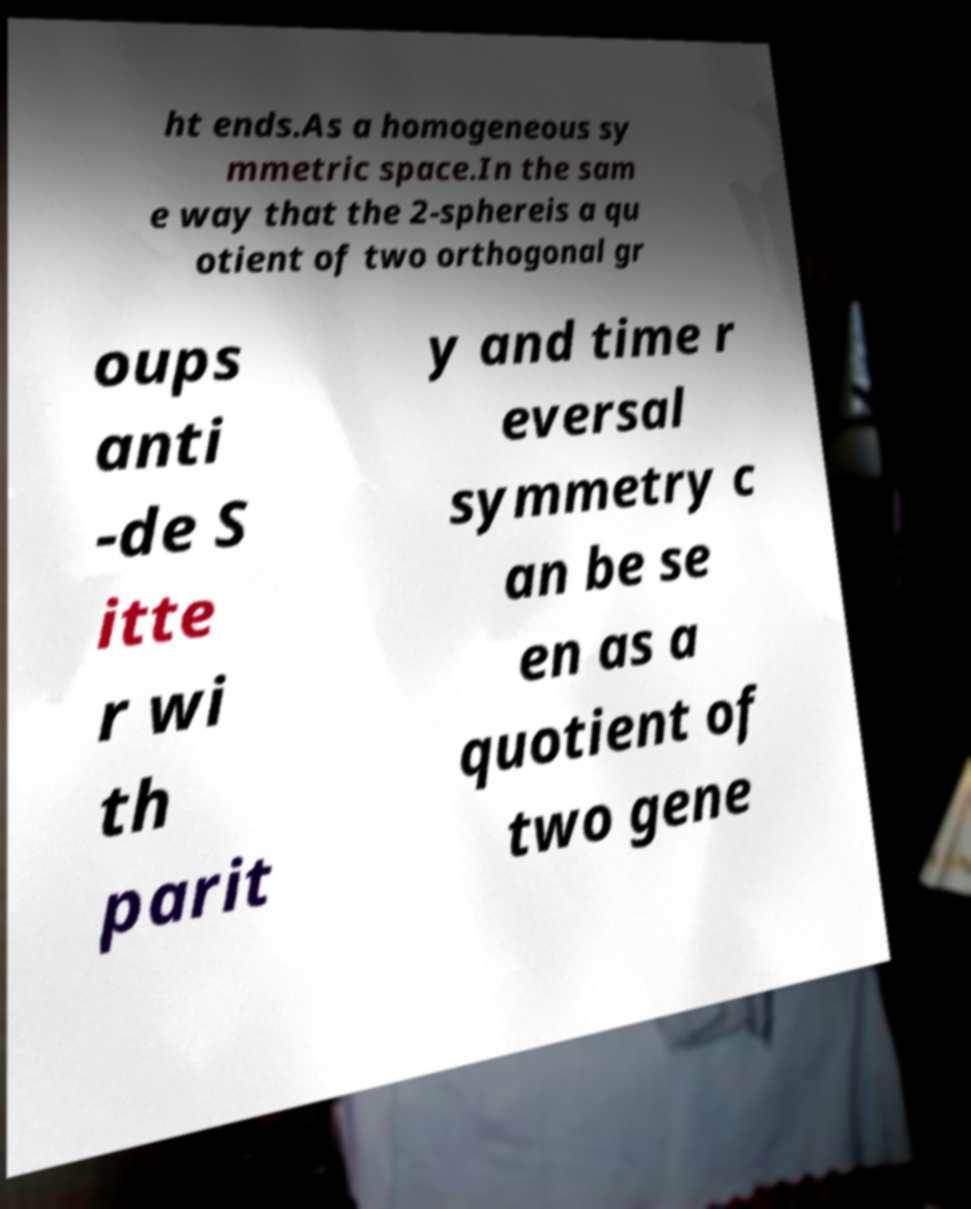Please read and relay the text visible in this image. What does it say? ht ends.As a homogeneous sy mmetric space.In the sam e way that the 2-sphereis a qu otient of two orthogonal gr oups anti -de S itte r wi th parit y and time r eversal symmetry c an be se en as a quotient of two gene 